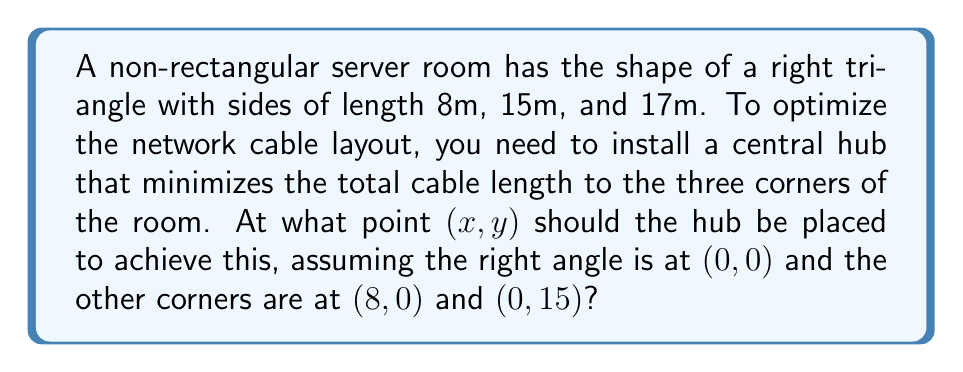What is the answer to this math problem? To solve this problem, we'll use the concept of the Fermat point (also known as the Torricelli point) in a triangle, which minimizes the sum of distances to all three vertices. For a right triangle, the Fermat point is located at the intersection of the altitude from the right angle and the semicircle drawn on the hypotenuse.

Step 1: Identify the triangle's vertices
A(0, 0), B(8, 0), C(0, 15)

Step 2: Find the center of the semicircle
The center is the midpoint of the hypotenuse:
$$ x_center = \frac{8}{2} = 4 $$
$$ y_center = \frac{15}{2} = 7.5 $$

Step 3: Find the radius of the semicircle
The radius is half the length of the hypotenuse:
$$ r = \frac{17}{2} = 8.5 $$

Step 4: Find the equation of the altitude from the right angle
The altitude is the line x = y * (8/15)

Step 5: Find the intersection of the altitude and the semicircle
Use the equations:
$$ x = y * \frac{8}{15} $$
$$ (x - 4)^2 + (y - 7.5)^2 = 8.5^2 $$

Substituting the first equation into the second:
$$ (y * \frac{8}{15} - 4)^2 + (y - 7.5)^2 = 8.5^2 $$

Solving this equation (which can be done using a calculator or computer algebra system):
$$ y \approx 5.7735 $$
$$ x \approx 3.0792 $$

Therefore, the optimal point for the central hub is approximately (3.0792, 5.7735).

[asy]
import geometry;

size(200);
draw((0,0)--(8,0)--(0,15)--cycle);
draw(arc((4,7.5), 8.5, 180, 360), dashed);
dot((3.0792,5.7735), red);
label("A(0,0)", (0,0), SW);
label("B(8,0)", (8,0), SE);
label("C(0,15)", (0,15), NW);
label("Hub", (3.0792,5.7735), NE);
[/asy]
Answer: (3.0792, 5.7735) 